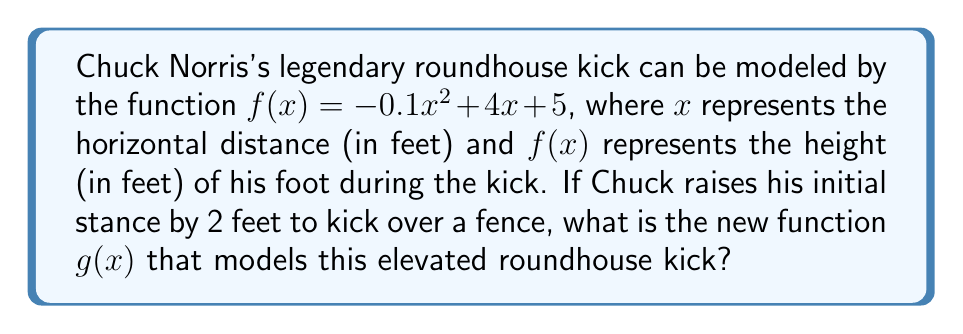Show me your answer to this math problem. To solve this problem, we need to understand vertical shifts in functions:

1) A vertical shift of a function $f(x)$ by $k$ units up is represented by $f(x) + k$.

2) In this case, Chuck is raising his stance by 2 feet, which means we need to shift the entire function up by 2 units.

3) The original function is $f(x) = -0.1x^2 + 4x + 5$.

4) To shift this function up by 2 units, we add 2 to the function:

   $g(x) = f(x) + 2$
   $g(x) = (-0.1x^2 + 4x + 5) + 2$

5) Simplify by combining like terms:

   $g(x) = -0.1x^2 + 4x + 7$

This new function $g(x)$ represents Chuck's elevated roundhouse kick, with every point of the trajectory now 2 feet higher than before.
Answer: $g(x) = -0.1x^2 + 4x + 7$ 